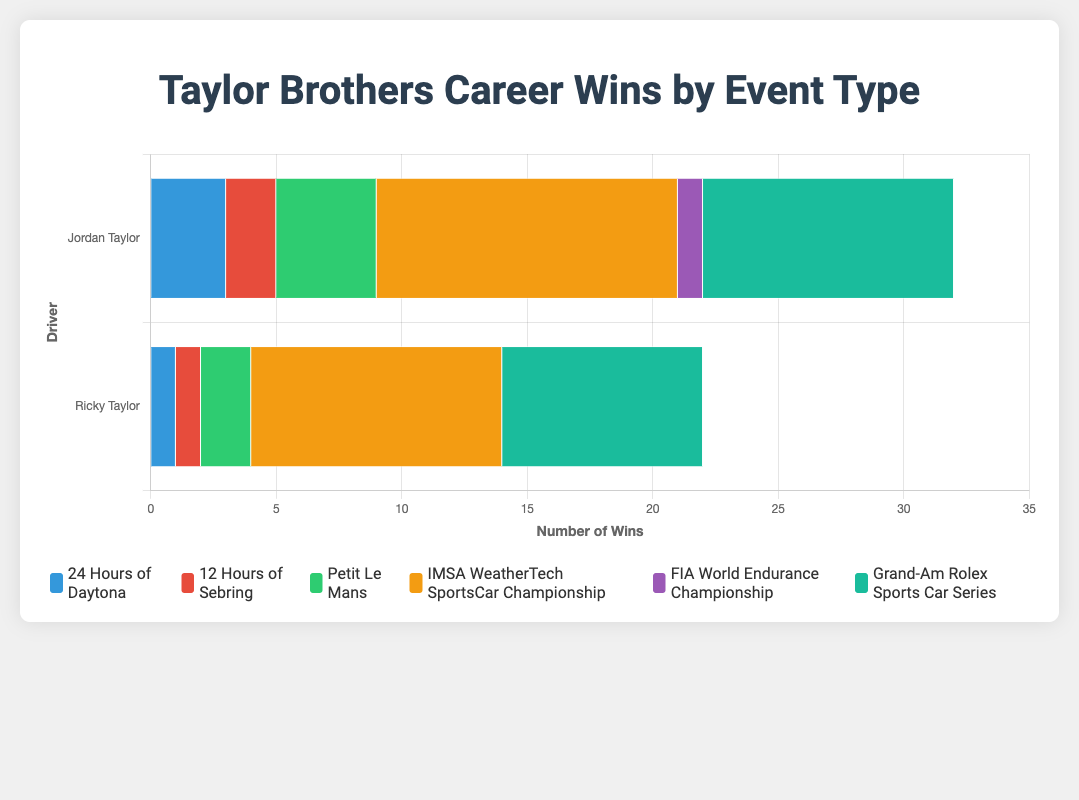Which driver has more total career wins? We need to sum up the wins from all event types for both drivers. Jordan Taylor's total wins are \(3 + 2 + 4 + 12 + 1 + 10 = 32\). Ricky Taylor's total wins are \(1 + 1 + 2 + 10 + 0 + 8 = 22\). So Jordan Taylor has more total career wins.
Answer: Jordan Taylor For which event does Jordan Taylor have the highest number of wins? Looking at the stacked bar for Jordan Taylor, the longest bar corresponding to an event is for the IMSA WeatherTech SportsCar Championship with 12 wins.
Answer: IMSA WeatherTech SportsCar Championship How many more wins does Jordan Taylor have in the "24 Hours of Daytona" compared to Ricky Taylor? Jordan Taylor has 3 wins, and Ricky Taylor has 1 win in the 24 Hours of Daytona. The difference is \(3 - 1 = 2\).
Answer: 2 Which driver has more wins in the Grand-Am Rolex Sports Car Series? Comparing the bar lengths for the Grand-Am Rolex Sports Car Series, Jordan Taylor has 10 wins, and Ricky Taylor has 8 wins. Jordan has 2 more wins.
Answer: Jordan Taylor What is the total number of wins by both drivers in Petit Le Mans? Jordan Taylor has 4 wins, and Ricky Taylor has 2 wins in Petit Le Mans. Summing these, \(4 + 2 = 6\).
Answer: 6 Who has zero wins in any event type, and which event is it? Ricky Taylor has zero wins in the FIA World Endurance Championship, which is indicated by the absence of a bar segment for Ricky in that event.
Answer: Ricky Taylor, FIA World Endurance Championship Does any driver have an equal number of wins in any event type, and which event is it? Both Jordan and Ricky Taylor have 10 wins in the IMSA WeatherTech SportsCar Championship, indicated by equal bar lengths for this event.
Answer: IMSA WeatherTech SportsCar Championship Which event has the smallest overall number of wins for both drivers combined? The FIA World Endurance Championship has the smallest combined wins since Jordan has 1 win and Ricky has 0 wins, making a total of \(1 + 0 = 1\).
Answer: FIA World Endurance Championship What is the average number of wins per event for Jordan Taylor? Total wins for Jordan Taylor are 32. There are 6 event types. The average is \(32 / 6 \approx 5.33\).
Answer: ~5.33 